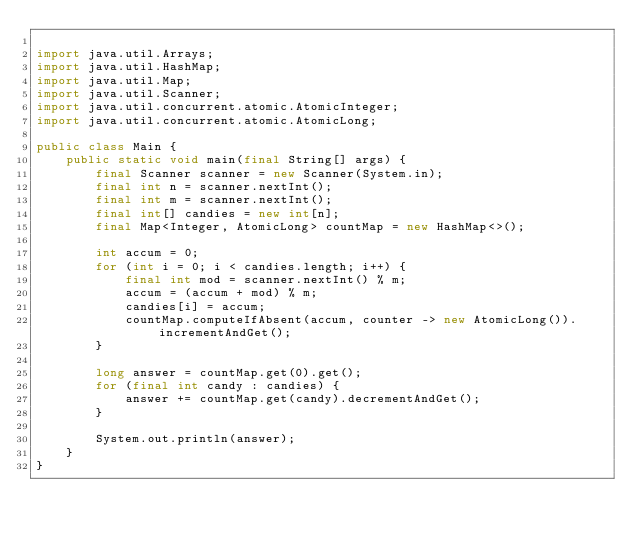Convert code to text. <code><loc_0><loc_0><loc_500><loc_500><_Java_>
import java.util.Arrays;
import java.util.HashMap;
import java.util.Map;
import java.util.Scanner;
import java.util.concurrent.atomic.AtomicInteger;
import java.util.concurrent.atomic.AtomicLong;

public class Main {
    public static void main(final String[] args) {
        final Scanner scanner = new Scanner(System.in);
        final int n = scanner.nextInt();
        final int m = scanner.nextInt();
        final int[] candies = new int[n];
        final Map<Integer, AtomicLong> countMap = new HashMap<>();

        int accum = 0;
        for (int i = 0; i < candies.length; i++) {
            final int mod = scanner.nextInt() % m;
            accum = (accum + mod) % m;
            candies[i] = accum;
            countMap.computeIfAbsent(accum, counter -> new AtomicLong()).incrementAndGet();
        }

        long answer = countMap.get(0).get();
        for (final int candy : candies) {
            answer += countMap.get(candy).decrementAndGet();
        }

        System.out.println(answer);
    }
}
</code> 